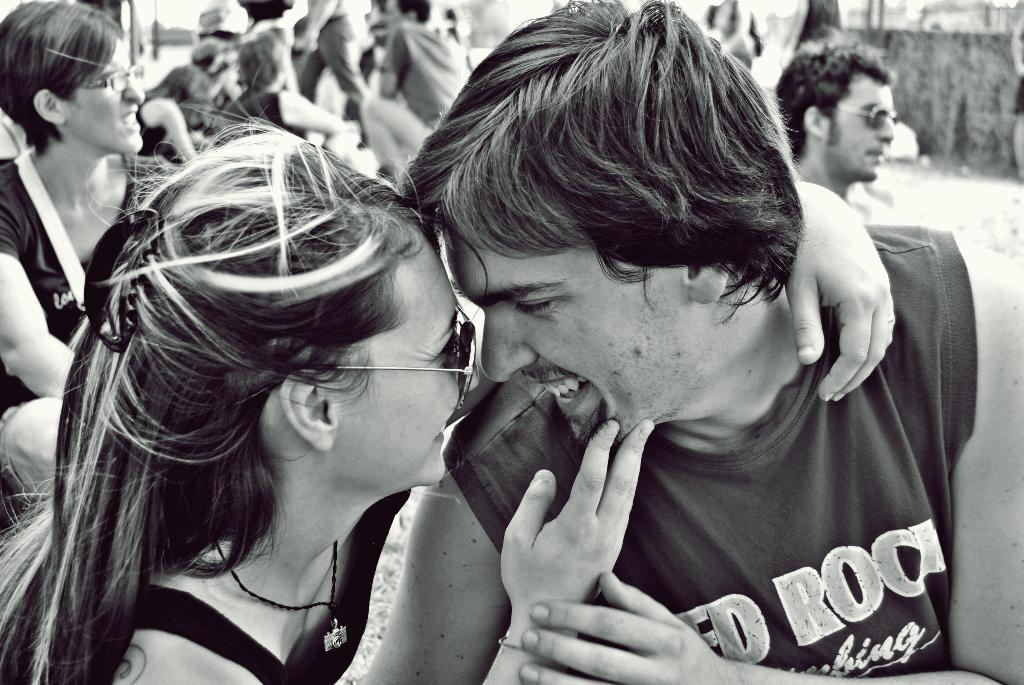How many people are present in the image? There are two people in the image, a man and a woman. What are the man and woman doing in the image? The man and woman are standing and holding each other, and they are both smiling. Can you describe the people in the background of the image? There are people sitting in the background of the image. What type of fiction is the man reading to the woman in the image? There is no book or any form of fiction present in the image; the man and woman are simply standing and holding each other. Can you tell me how many baskets are visible in the image? There are no baskets present in the image. 